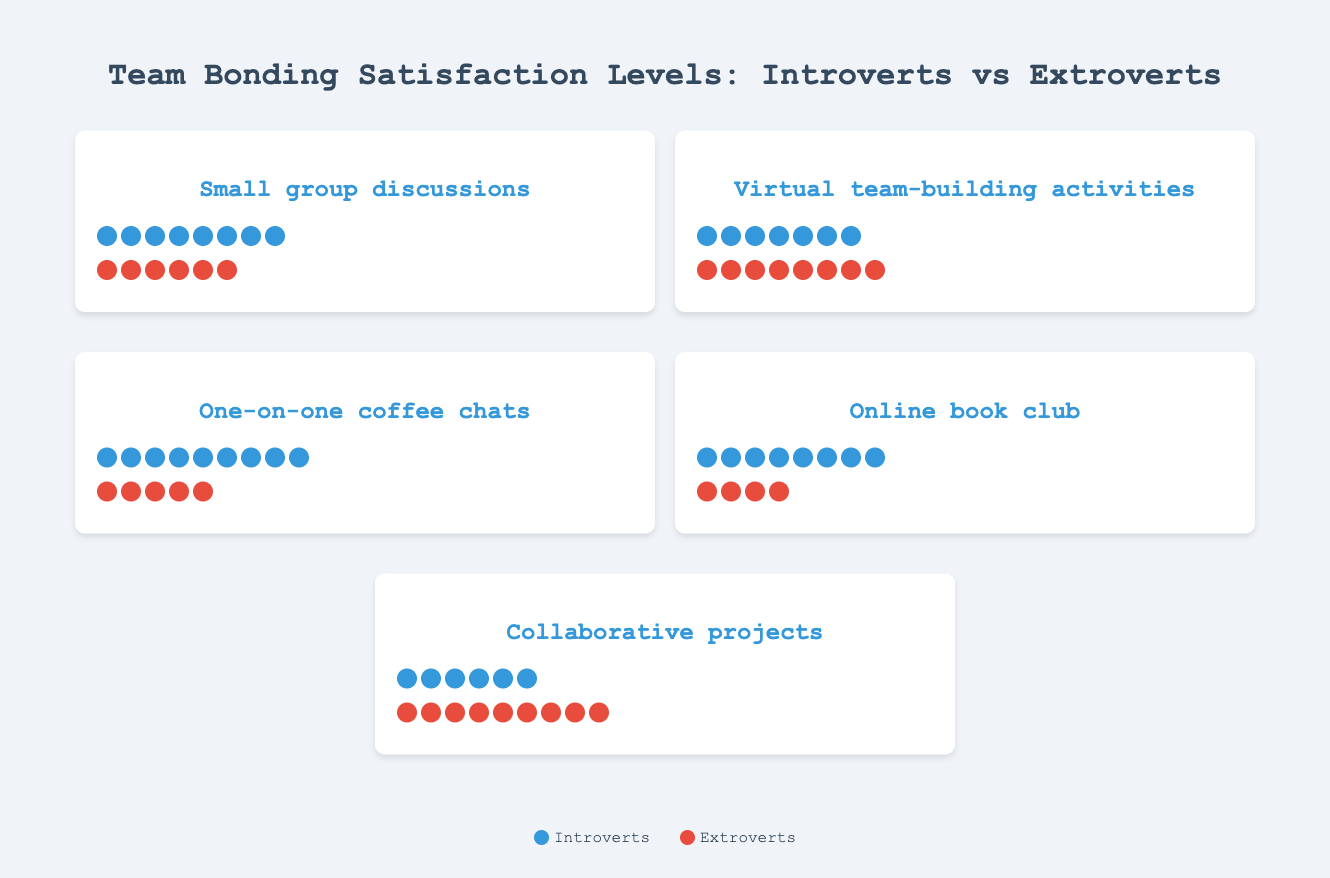How many icons represent introvert satisfaction with small group discussions? The figure shows that each icon represents a satisfaction level of 1/10. There are 8 introvert icons for small group discussions.
Answer: 8 How satisfied are extroverts with one-on-one coffee chats? The figure displays extrovert satisfaction as 5/10 for one-on-one coffee chats, represented by 5 icons.
Answer: 5 Which group shows higher satisfaction with virtual team-building activities? By counting the icons, introverts have 7 icons while extroverts have 8, indicating higher satisfaction for extroverts.
Answer: Extroverts What is the difference in satisfaction levels between introverts and extroverts for collaborative projects? Introverts have a satisfaction level of 6/10, and extroverts have 9/10 for collaborative projects. The difference is 9 - 6 = 3.
Answer: 3 Which activity do introverts find most satisfying? For introverts, the highest satisfaction level is 9/10, which is represented by the most icons for one-on-one coffee chats.
Answer: One-on-one coffee chats Do extroverts prefer virtual team-building activities or online book clubs? By comparing the number of icons, extroverts have 8 icons for virtual team-building activities and 4 icons for online book clubs. They prefer virtual team-building activities.
Answer: Virtual team-building activities What's the total satisfaction score for introverts across all activities? The satisfaction scores for introverts are 8, 7, 9, 8, and 6 respectively. Summing these gives 8 + 7 + 9 + 8 + 6 = 38.
Answer: 38 Which activity has the smallest difference in satisfaction levels between introverts and extroverts? The differences are calculated as follows: Small group discussions (8-6=2), Virtual team-building activities (8-7=1), One-on-one coffee chats (9-5=4), Online book club (8-4=4), Collaborative projects (9-6=3). The smallest difference is 1, for virtual team-building activities.
Answer: Virtual team-building activities Is there any activity where extroverts' satisfaction is more than double that of introverts? We need to check if any satisfaction level for extroverts is more than twice that of introverts: Small group discussions (6 not > 2*8), Virtual team-building activities (8 not > 2*7), One-on-one coffee chats (5 not > 2*9), Online book club (4 not > 2*8), Collaborative projects (9 > 2*6). Thus, no activity meets this criterion.
Answer: No 